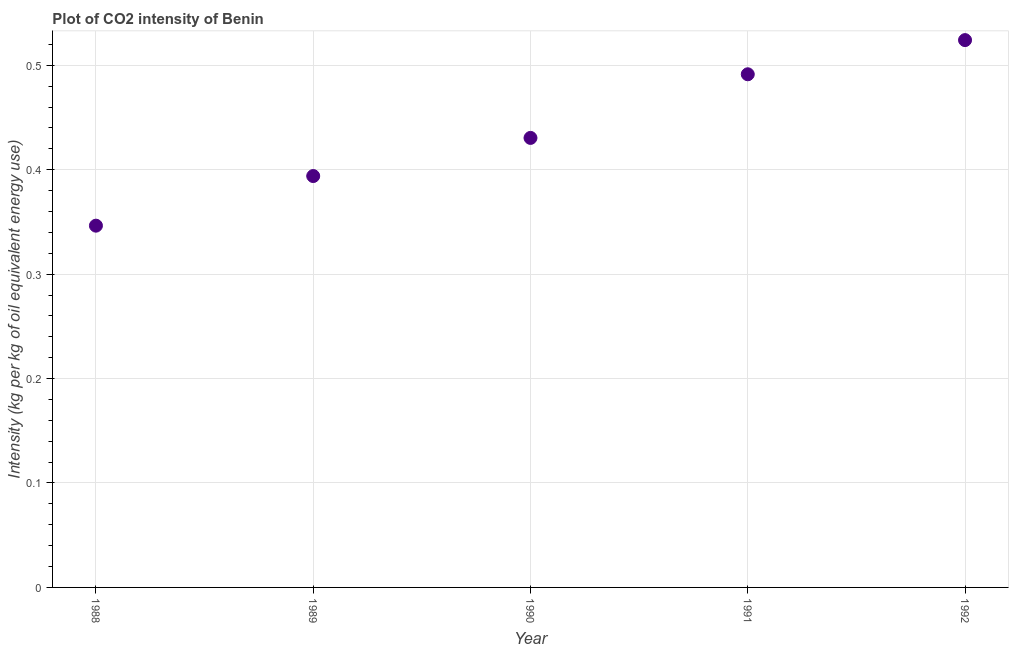What is the co2 intensity in 1992?
Offer a terse response. 0.52. Across all years, what is the maximum co2 intensity?
Give a very brief answer. 0.52. Across all years, what is the minimum co2 intensity?
Your answer should be compact. 0.35. In which year was the co2 intensity minimum?
Offer a terse response. 1988. What is the sum of the co2 intensity?
Your answer should be compact. 2.19. What is the difference between the co2 intensity in 1989 and 1991?
Offer a terse response. -0.1. What is the average co2 intensity per year?
Provide a short and direct response. 0.44. What is the median co2 intensity?
Your answer should be very brief. 0.43. In how many years, is the co2 intensity greater than 0.42000000000000004 kg?
Make the answer very short. 3. Do a majority of the years between 1988 and 1991 (inclusive) have co2 intensity greater than 0.38000000000000006 kg?
Ensure brevity in your answer.  Yes. What is the ratio of the co2 intensity in 1988 to that in 1992?
Your response must be concise. 0.66. Is the difference between the co2 intensity in 1990 and 1992 greater than the difference between any two years?
Make the answer very short. No. What is the difference between the highest and the second highest co2 intensity?
Provide a succinct answer. 0.03. What is the difference between the highest and the lowest co2 intensity?
Provide a succinct answer. 0.18. In how many years, is the co2 intensity greater than the average co2 intensity taken over all years?
Make the answer very short. 2. What is the difference between two consecutive major ticks on the Y-axis?
Keep it short and to the point. 0.1. Are the values on the major ticks of Y-axis written in scientific E-notation?
Give a very brief answer. No. Does the graph contain any zero values?
Your answer should be compact. No. What is the title of the graph?
Give a very brief answer. Plot of CO2 intensity of Benin. What is the label or title of the X-axis?
Ensure brevity in your answer.  Year. What is the label or title of the Y-axis?
Your answer should be very brief. Intensity (kg per kg of oil equivalent energy use). What is the Intensity (kg per kg of oil equivalent energy use) in 1988?
Provide a short and direct response. 0.35. What is the Intensity (kg per kg of oil equivalent energy use) in 1989?
Provide a short and direct response. 0.39. What is the Intensity (kg per kg of oil equivalent energy use) in 1990?
Offer a terse response. 0.43. What is the Intensity (kg per kg of oil equivalent energy use) in 1991?
Offer a very short reply. 0.49. What is the Intensity (kg per kg of oil equivalent energy use) in 1992?
Ensure brevity in your answer.  0.52. What is the difference between the Intensity (kg per kg of oil equivalent energy use) in 1988 and 1989?
Offer a terse response. -0.05. What is the difference between the Intensity (kg per kg of oil equivalent energy use) in 1988 and 1990?
Your response must be concise. -0.08. What is the difference between the Intensity (kg per kg of oil equivalent energy use) in 1988 and 1991?
Provide a short and direct response. -0.14. What is the difference between the Intensity (kg per kg of oil equivalent energy use) in 1988 and 1992?
Offer a terse response. -0.18. What is the difference between the Intensity (kg per kg of oil equivalent energy use) in 1989 and 1990?
Give a very brief answer. -0.04. What is the difference between the Intensity (kg per kg of oil equivalent energy use) in 1989 and 1991?
Your response must be concise. -0.1. What is the difference between the Intensity (kg per kg of oil equivalent energy use) in 1989 and 1992?
Offer a very short reply. -0.13. What is the difference between the Intensity (kg per kg of oil equivalent energy use) in 1990 and 1991?
Provide a short and direct response. -0.06. What is the difference between the Intensity (kg per kg of oil equivalent energy use) in 1990 and 1992?
Ensure brevity in your answer.  -0.09. What is the difference between the Intensity (kg per kg of oil equivalent energy use) in 1991 and 1992?
Provide a short and direct response. -0.03. What is the ratio of the Intensity (kg per kg of oil equivalent energy use) in 1988 to that in 1989?
Provide a short and direct response. 0.88. What is the ratio of the Intensity (kg per kg of oil equivalent energy use) in 1988 to that in 1990?
Make the answer very short. 0.81. What is the ratio of the Intensity (kg per kg of oil equivalent energy use) in 1988 to that in 1991?
Give a very brief answer. 0.7. What is the ratio of the Intensity (kg per kg of oil equivalent energy use) in 1988 to that in 1992?
Your answer should be very brief. 0.66. What is the ratio of the Intensity (kg per kg of oil equivalent energy use) in 1989 to that in 1990?
Your response must be concise. 0.92. What is the ratio of the Intensity (kg per kg of oil equivalent energy use) in 1989 to that in 1991?
Give a very brief answer. 0.8. What is the ratio of the Intensity (kg per kg of oil equivalent energy use) in 1989 to that in 1992?
Keep it short and to the point. 0.75. What is the ratio of the Intensity (kg per kg of oil equivalent energy use) in 1990 to that in 1991?
Provide a succinct answer. 0.88. What is the ratio of the Intensity (kg per kg of oil equivalent energy use) in 1990 to that in 1992?
Ensure brevity in your answer.  0.82. What is the ratio of the Intensity (kg per kg of oil equivalent energy use) in 1991 to that in 1992?
Provide a succinct answer. 0.94. 